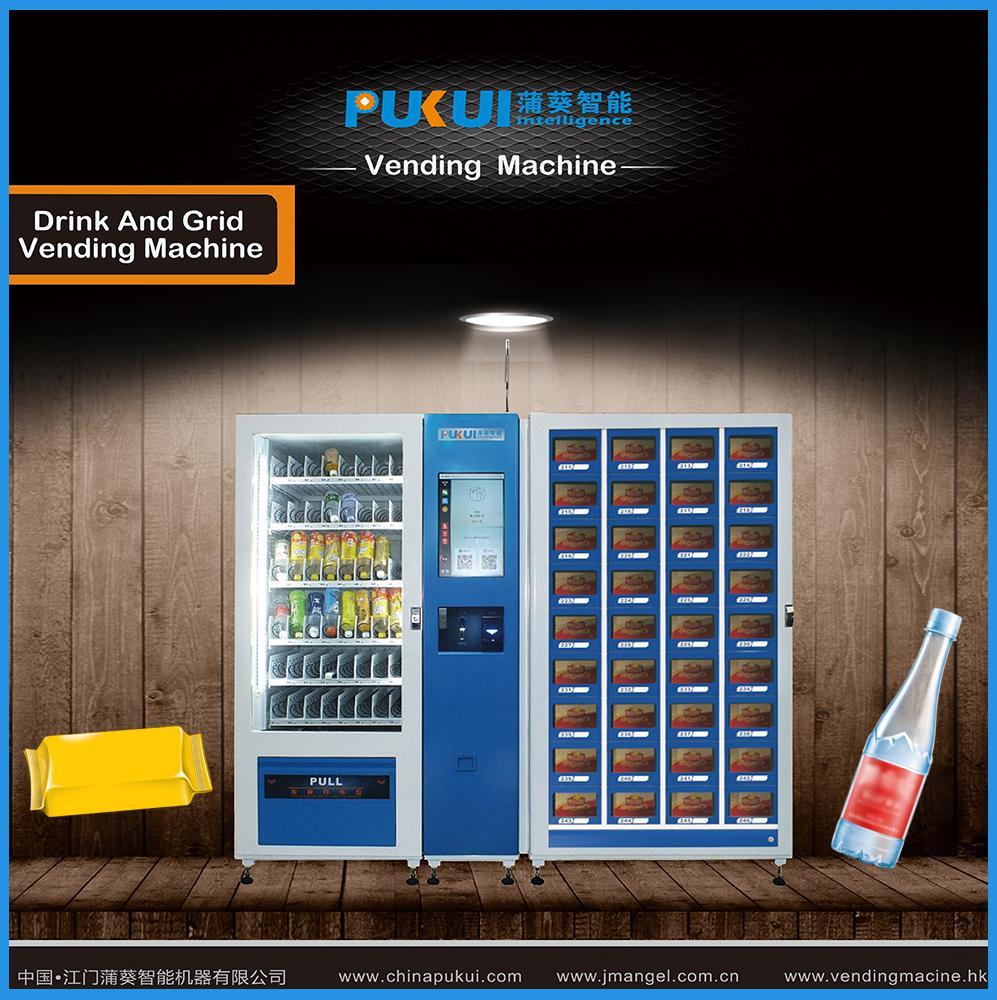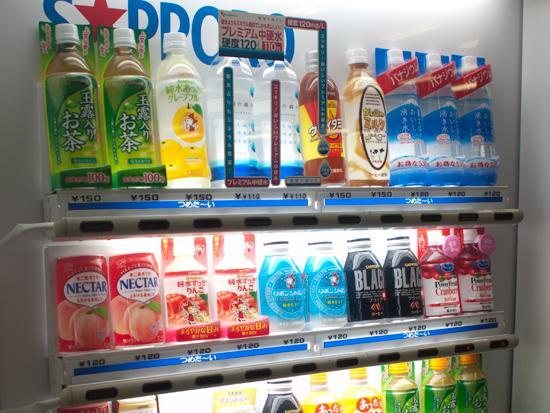The first image is the image on the left, the second image is the image on the right. For the images displayed, is the sentence "Only three shelves of items are visible in the vending machine in the image on the left" factually correct? Answer yes or no. No. 